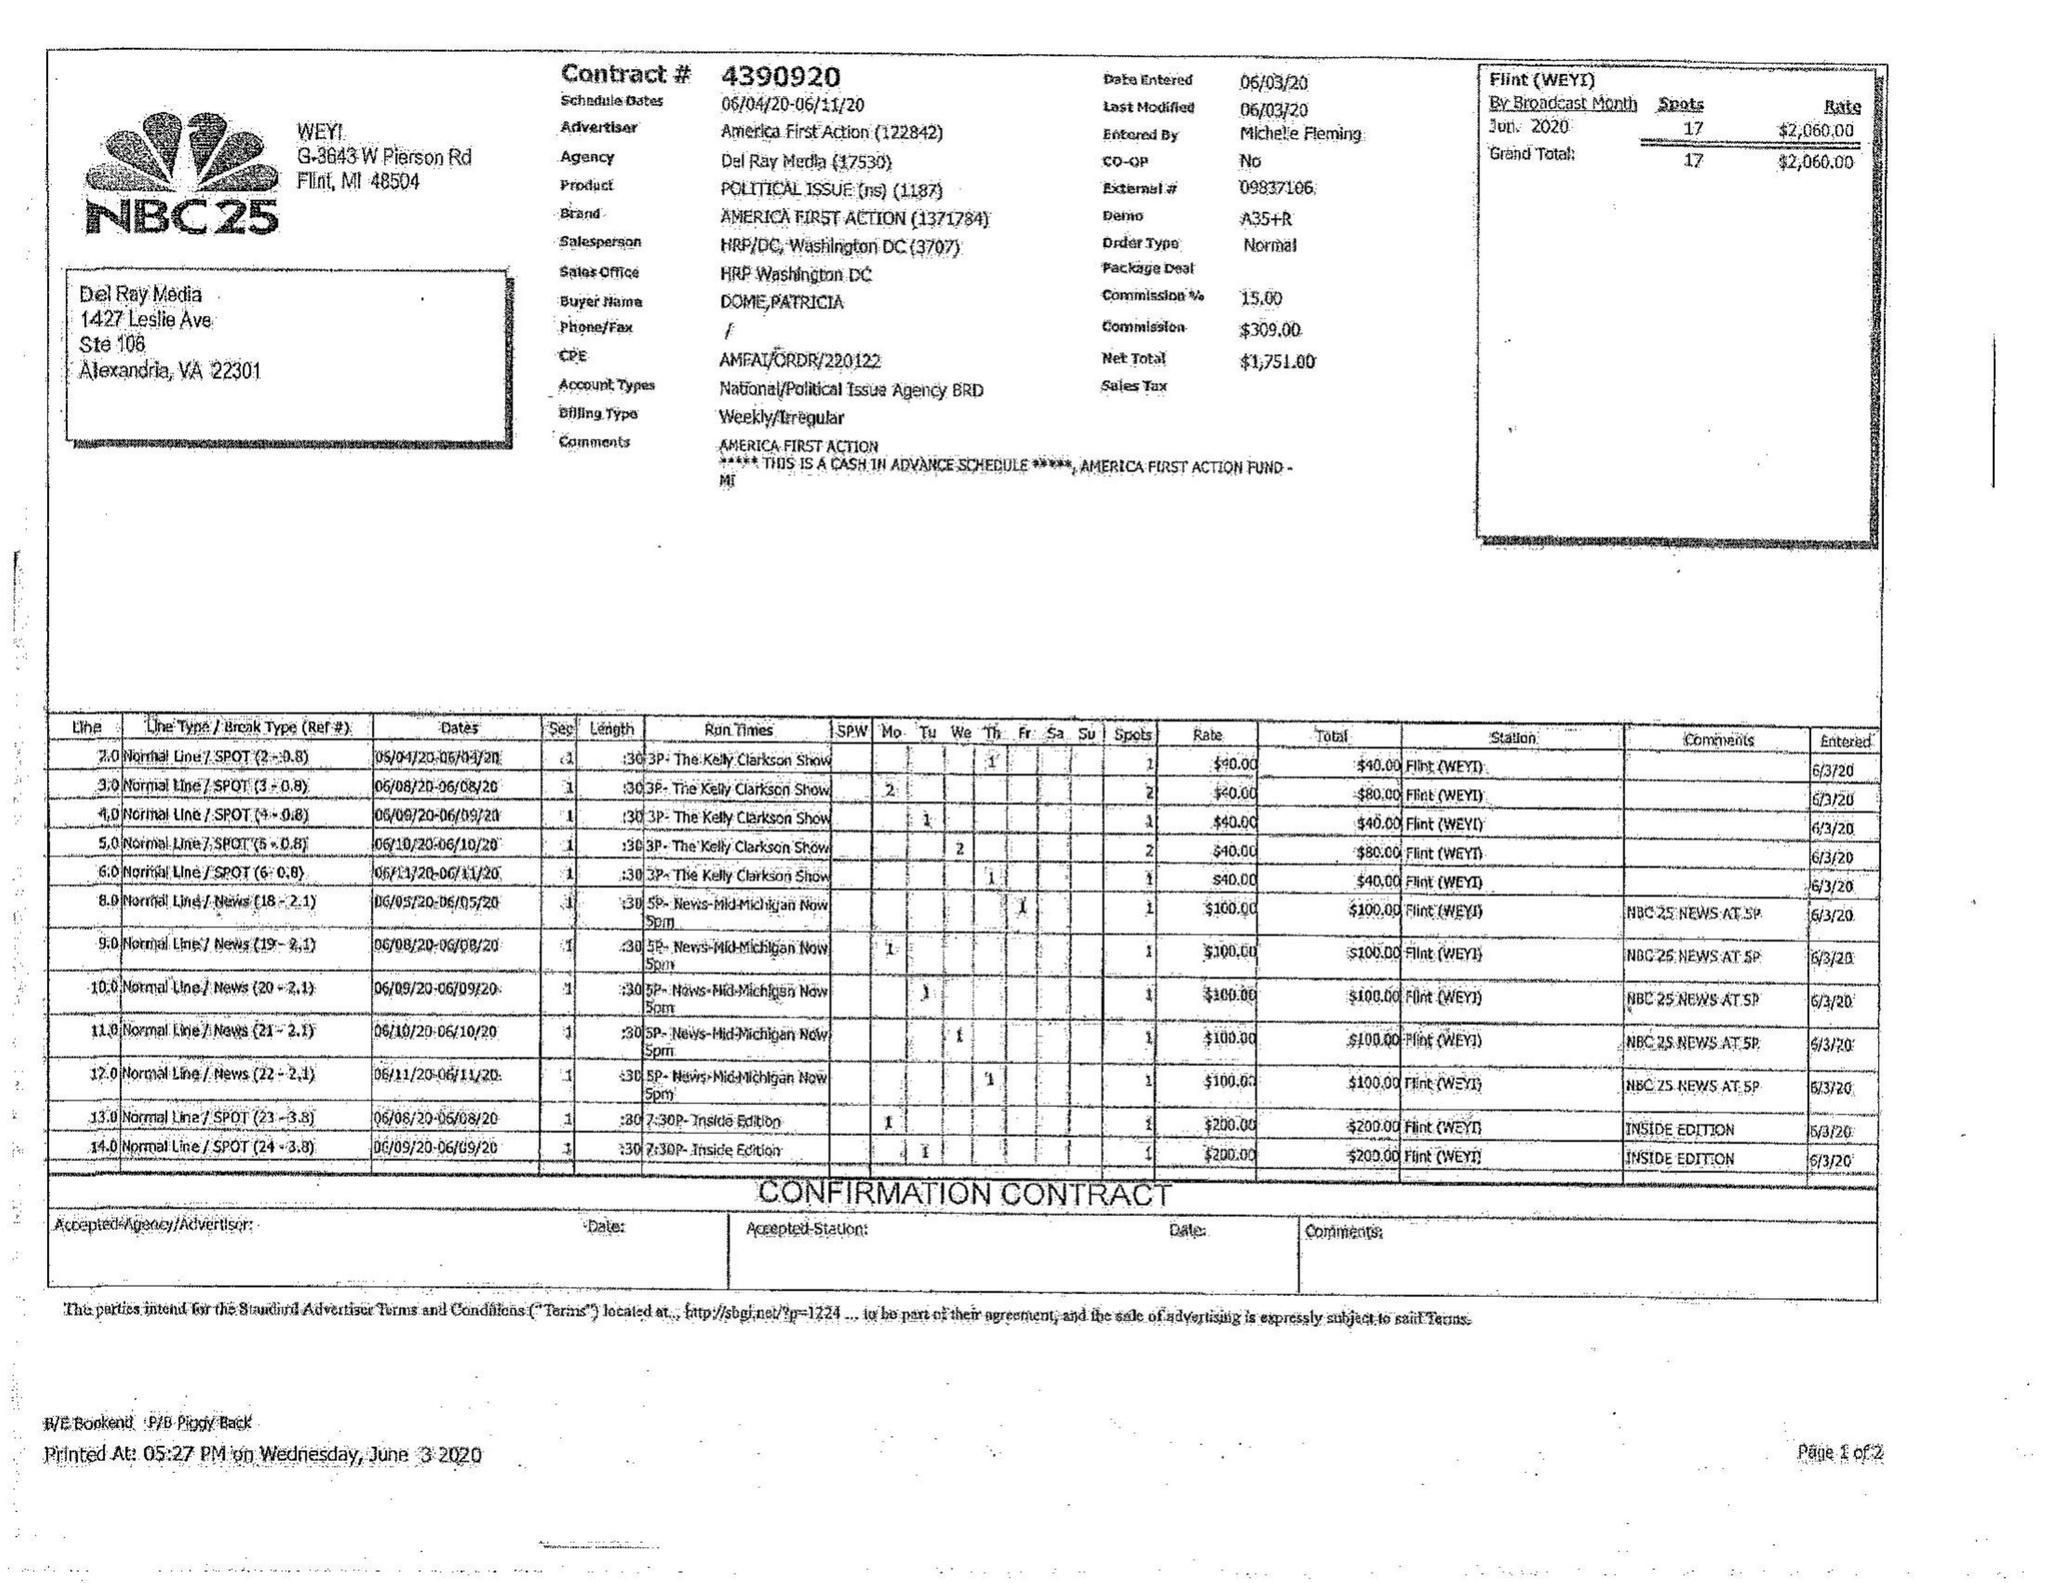What is the value for the flight_from?
Answer the question using a single word or phrase. 06/04/20 